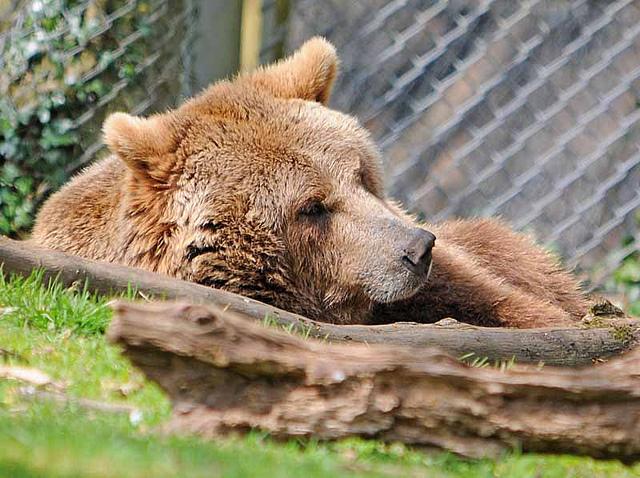What is on the ground in front of the bear?
Give a very brief answer. Log. What color is the bear?
Answer briefly. Brown. Is the bear in a bad mood?
Short answer required. No. 